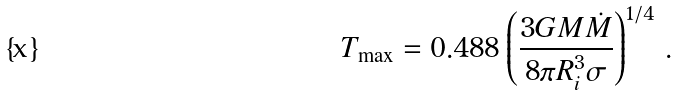<formula> <loc_0><loc_0><loc_500><loc_500>T _ { \max } = 0 . 4 8 8 \left ( \frac { 3 G M \dot { M } } { 8 \pi R _ { i } ^ { 3 } \sigma } \right ) ^ { 1 / 4 } \, .</formula> 